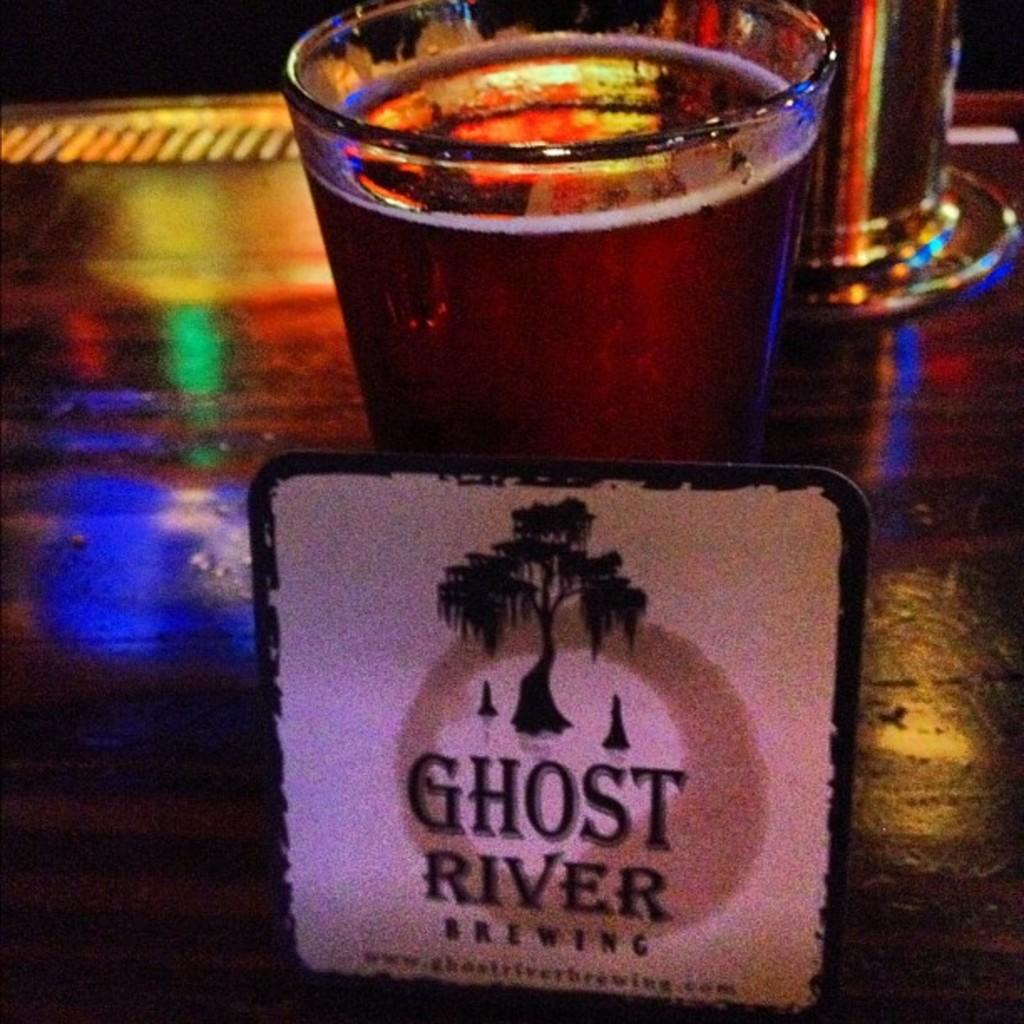<image>
Offer a succinct explanation of the picture presented. A tall glass of beer with a placard reading "Ghost River Brewing" in front of it. 